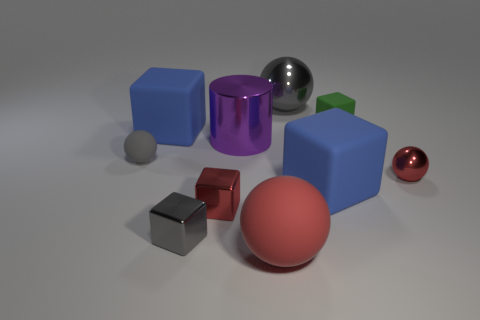There is a cube that is the same color as the big rubber ball; what material is it?
Offer a very short reply. Metal. What number of other objects are the same color as the large metallic sphere?
Offer a terse response. 2. What number of other objects are there of the same shape as the big red rubber object?
Offer a very short reply. 3. How many tiny gray shiny cubes are on the right side of the red shiny sphere?
Offer a very short reply. 0. There is a gray shiny block that is in front of the red block; is it the same size as the matte ball in front of the gray block?
Ensure brevity in your answer.  No. What number of other objects are the same size as the green object?
Ensure brevity in your answer.  4. What is the material of the small red object that is to the left of the small object that is behind the blue cube behind the big purple shiny object?
Your answer should be very brief. Metal. Do the purple shiny object and the red shiny object to the right of the green rubber object have the same size?
Give a very brief answer. No. How big is the matte block that is both in front of the small green matte thing and to the right of the metallic cylinder?
Offer a terse response. Large. Are there any metallic blocks of the same color as the big rubber ball?
Your answer should be very brief. Yes. 